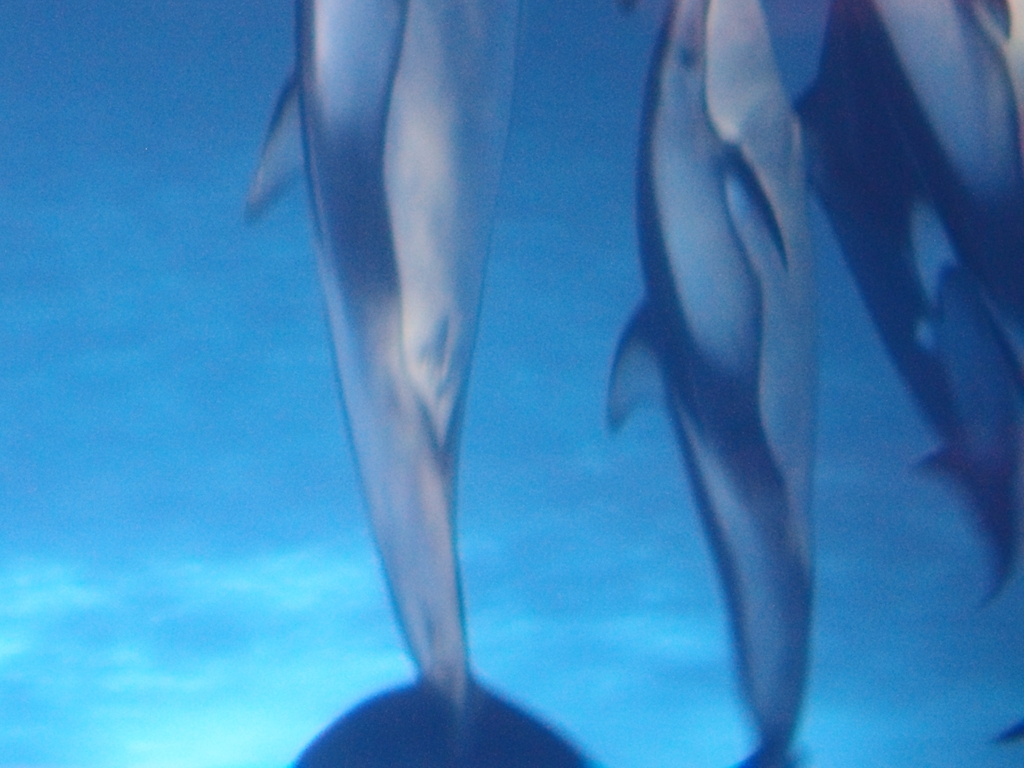How would you rate the composition of the image? The image composition has elements that could be improved. It seems to capture dolphins from an underwater perspective, but the focus is not sharp, and the subjects are not framed effectively. By adjusting the focus and composition to better emphasize the dolphins, the overall aesthetic and impact of the photograph could be enhanced. 